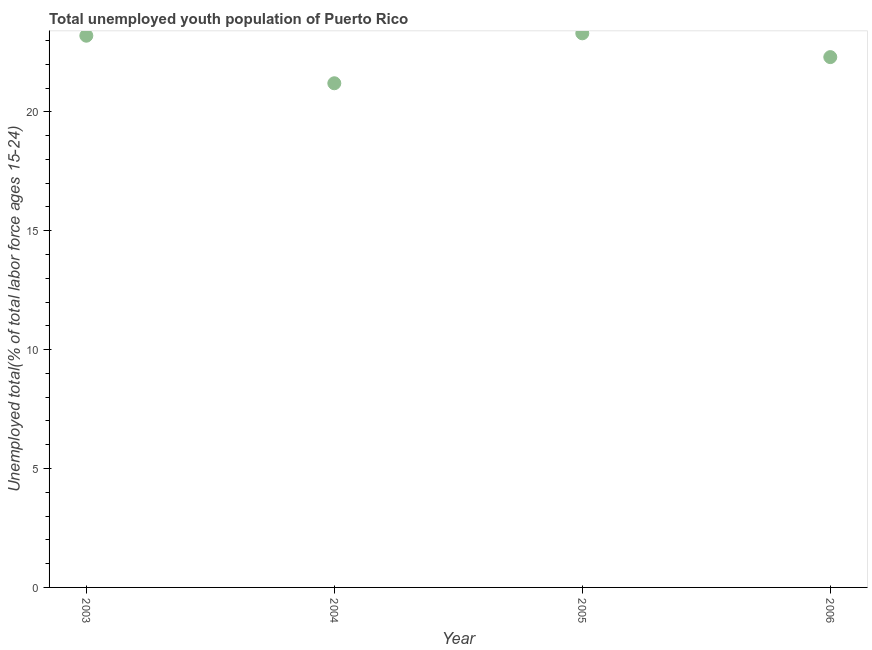What is the unemployed youth in 2004?
Offer a very short reply. 21.2. Across all years, what is the maximum unemployed youth?
Make the answer very short. 23.3. Across all years, what is the minimum unemployed youth?
Give a very brief answer. 21.2. What is the sum of the unemployed youth?
Provide a short and direct response. 90. What is the difference between the unemployed youth in 2004 and 2006?
Offer a very short reply. -1.1. What is the average unemployed youth per year?
Your answer should be compact. 22.5. What is the median unemployed youth?
Offer a terse response. 22.75. What is the ratio of the unemployed youth in 2004 to that in 2005?
Your answer should be very brief. 0.91. Is the unemployed youth in 2003 less than that in 2004?
Your answer should be very brief. No. What is the difference between the highest and the second highest unemployed youth?
Offer a terse response. 0.1. Is the sum of the unemployed youth in 2005 and 2006 greater than the maximum unemployed youth across all years?
Keep it short and to the point. Yes. What is the difference between the highest and the lowest unemployed youth?
Keep it short and to the point. 2.1. How many years are there in the graph?
Keep it short and to the point. 4. Are the values on the major ticks of Y-axis written in scientific E-notation?
Offer a terse response. No. Does the graph contain grids?
Offer a terse response. No. What is the title of the graph?
Your response must be concise. Total unemployed youth population of Puerto Rico. What is the label or title of the Y-axis?
Offer a very short reply. Unemployed total(% of total labor force ages 15-24). What is the Unemployed total(% of total labor force ages 15-24) in 2003?
Keep it short and to the point. 23.2. What is the Unemployed total(% of total labor force ages 15-24) in 2004?
Your answer should be very brief. 21.2. What is the Unemployed total(% of total labor force ages 15-24) in 2005?
Keep it short and to the point. 23.3. What is the Unemployed total(% of total labor force ages 15-24) in 2006?
Give a very brief answer. 22.3. What is the difference between the Unemployed total(% of total labor force ages 15-24) in 2003 and 2005?
Offer a terse response. -0.1. What is the difference between the Unemployed total(% of total labor force ages 15-24) in 2003 and 2006?
Your answer should be compact. 0.9. What is the difference between the Unemployed total(% of total labor force ages 15-24) in 2005 and 2006?
Offer a very short reply. 1. What is the ratio of the Unemployed total(% of total labor force ages 15-24) in 2003 to that in 2004?
Your answer should be compact. 1.09. What is the ratio of the Unemployed total(% of total labor force ages 15-24) in 2003 to that in 2005?
Your response must be concise. 1. What is the ratio of the Unemployed total(% of total labor force ages 15-24) in 2004 to that in 2005?
Provide a short and direct response. 0.91. What is the ratio of the Unemployed total(% of total labor force ages 15-24) in 2004 to that in 2006?
Your response must be concise. 0.95. What is the ratio of the Unemployed total(% of total labor force ages 15-24) in 2005 to that in 2006?
Your answer should be very brief. 1.04. 